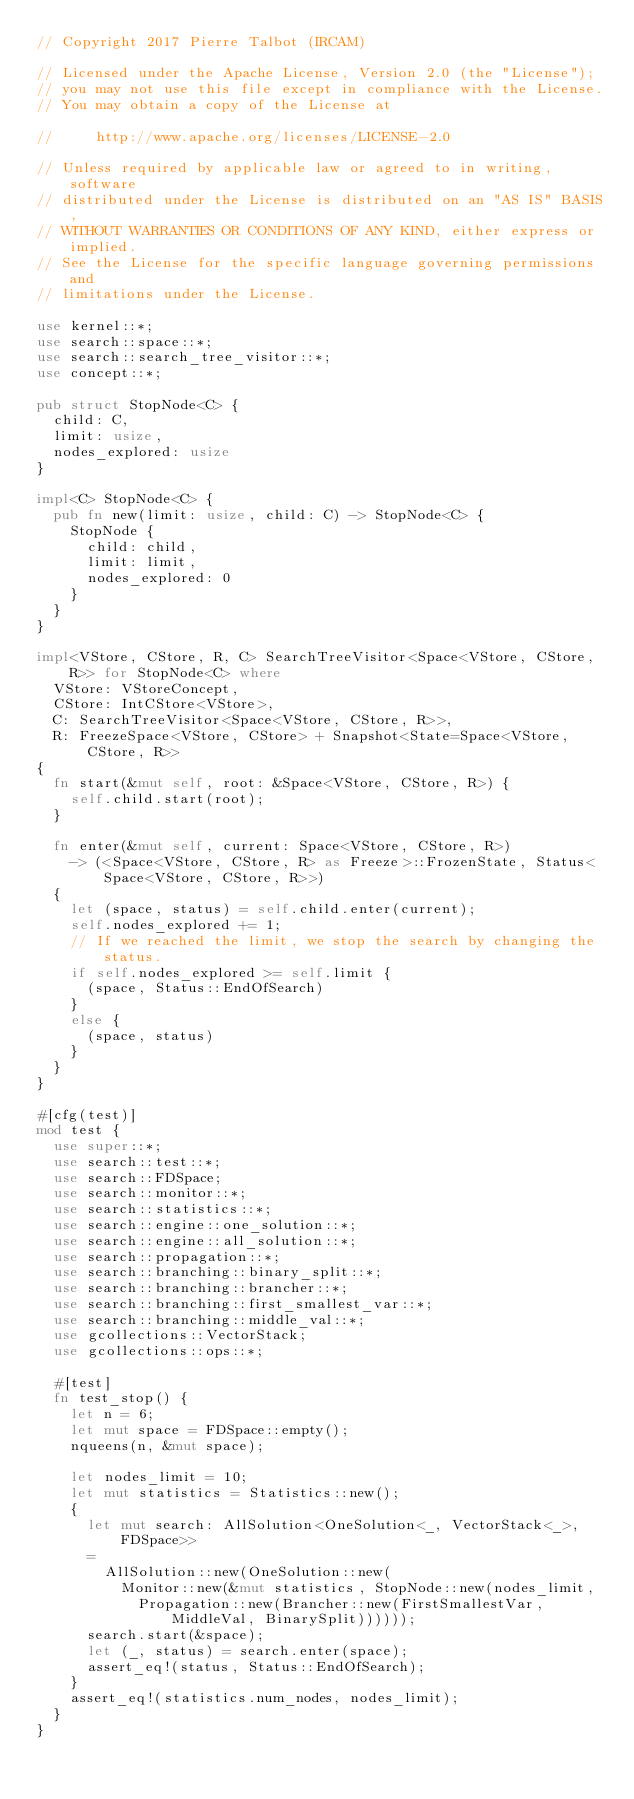<code> <loc_0><loc_0><loc_500><loc_500><_Rust_>// Copyright 2017 Pierre Talbot (IRCAM)

// Licensed under the Apache License, Version 2.0 (the "License");
// you may not use this file except in compliance with the License.
// You may obtain a copy of the License at

//     http://www.apache.org/licenses/LICENSE-2.0

// Unless required by applicable law or agreed to in writing, software
// distributed under the License is distributed on an "AS IS" BASIS,
// WITHOUT WARRANTIES OR CONDITIONS OF ANY KIND, either express or implied.
// See the License for the specific language governing permissions and
// limitations under the License.

use kernel::*;
use search::space::*;
use search::search_tree_visitor::*;
use concept::*;

pub struct StopNode<C> {
  child: C,
  limit: usize,
  nodes_explored: usize
}

impl<C> StopNode<C> {
  pub fn new(limit: usize, child: C) -> StopNode<C> {
    StopNode {
      child: child,
      limit: limit,
      nodes_explored: 0
    }
  }
}

impl<VStore, CStore, R, C> SearchTreeVisitor<Space<VStore, CStore, R>> for StopNode<C> where
  VStore: VStoreConcept,
  CStore: IntCStore<VStore>,
  C: SearchTreeVisitor<Space<VStore, CStore, R>>,
  R: FreezeSpace<VStore, CStore> + Snapshot<State=Space<VStore, CStore, R>>
{
  fn start(&mut self, root: &Space<VStore, CStore, R>) {
    self.child.start(root);
  }

  fn enter(&mut self, current: Space<VStore, CStore, R>)
    -> (<Space<VStore, CStore, R> as Freeze>::FrozenState, Status<Space<VStore, CStore, R>>)
  {
    let (space, status) = self.child.enter(current);
    self.nodes_explored += 1;
    // If we reached the limit, we stop the search by changing the status.
    if self.nodes_explored >= self.limit {
      (space, Status::EndOfSearch)
    }
    else {
      (space, status)
    }
  }
}

#[cfg(test)]
mod test {
  use super::*;
  use search::test::*;
  use search::FDSpace;
  use search::monitor::*;
  use search::statistics::*;
  use search::engine::one_solution::*;
  use search::engine::all_solution::*;
  use search::propagation::*;
  use search::branching::binary_split::*;
  use search::branching::brancher::*;
  use search::branching::first_smallest_var::*;
  use search::branching::middle_val::*;
  use gcollections::VectorStack;
  use gcollections::ops::*;

  #[test]
  fn test_stop() {
    let n = 6;
    let mut space = FDSpace::empty();
    nqueens(n, &mut space);

    let nodes_limit = 10;
    let mut statistics = Statistics::new();
    {
      let mut search: AllSolution<OneSolution<_, VectorStack<_>, FDSpace>>
      =
        AllSolution::new(OneSolution::new(
          Monitor::new(&mut statistics, StopNode::new(nodes_limit,
            Propagation::new(Brancher::new(FirstSmallestVar, MiddleVal, BinarySplit))))));
      search.start(&space);
      let (_, status) = search.enter(space);
      assert_eq!(status, Status::EndOfSearch);
    }
    assert_eq!(statistics.num_nodes, nodes_limit);
  }
}
</code> 